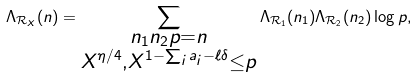<formula> <loc_0><loc_0><loc_500><loc_500>\Lambda _ { \mathcal { R } _ { X } } ( n ) = \sum _ { \substack { n _ { 1 } n _ { 2 } p = n \\ X ^ { \eta / 4 } , X ^ { 1 - \sum _ { i } a _ { i } - \ell \delta } \leq p } } \Lambda _ { \mathcal { R } _ { 1 } } ( n _ { 1 } ) \Lambda _ { \mathcal { R } _ { 2 } } ( n _ { 2 } ) \log { p } ,</formula> 